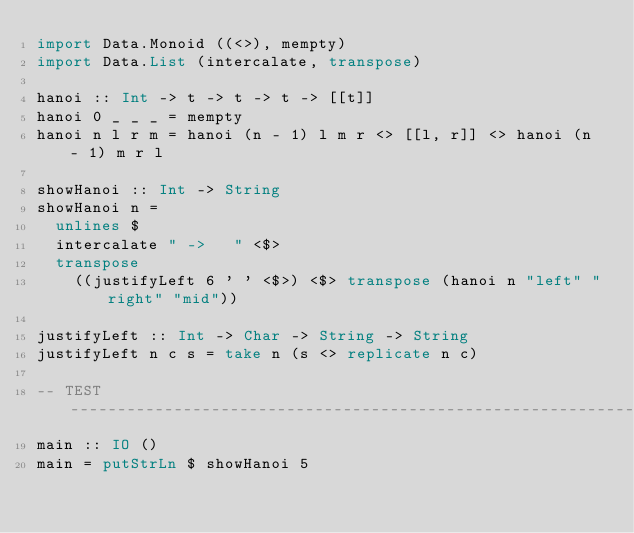Convert code to text. <code><loc_0><loc_0><loc_500><loc_500><_Haskell_>import Data.Monoid ((<>), mempty)
import Data.List (intercalate, transpose)

hanoi :: Int -> t -> t -> t -> [[t]]
hanoi 0 _ _ _ = mempty
hanoi n l r m = hanoi (n - 1) l m r <> [[l, r]] <> hanoi (n - 1) m r l

showHanoi :: Int -> String
showHanoi n =
  unlines $
  intercalate " ->   " <$>
  transpose
    ((justifyLeft 6 ' ' <$>) <$> transpose (hanoi n "left" "right" "mid"))

justifyLeft :: Int -> Char -> String -> String
justifyLeft n c s = take n (s <> replicate n c)

-- TEST -------------------------------------------------------------
main :: IO ()
main = putStrLn $ showHanoi 5
</code> 